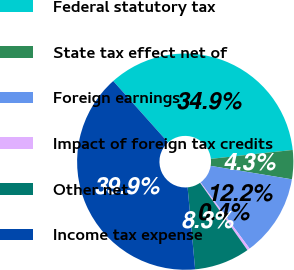Convert chart. <chart><loc_0><loc_0><loc_500><loc_500><pie_chart><fcel>Federal statutory tax<fcel>State tax effect net of<fcel>Foreign earnings<fcel>Impact of foreign tax credits<fcel>Other net<fcel>Income tax expense<nl><fcel>34.87%<fcel>4.34%<fcel>12.24%<fcel>0.4%<fcel>8.29%<fcel>39.86%<nl></chart> 